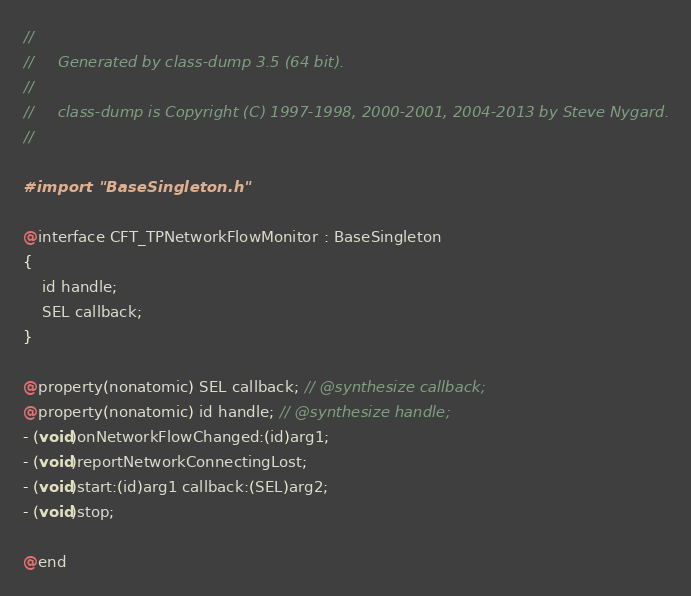<code> <loc_0><loc_0><loc_500><loc_500><_C_>//
//     Generated by class-dump 3.5 (64 bit).
//
//     class-dump is Copyright (C) 1997-1998, 2000-2001, 2004-2013 by Steve Nygard.
//

#import "BaseSingleton.h"

@interface CFT_TPNetworkFlowMonitor : BaseSingleton
{
    id handle;
    SEL callback;
}

@property(nonatomic) SEL callback; // @synthesize callback;
@property(nonatomic) id handle; // @synthesize handle;
- (void)onNetworkFlowChanged:(id)arg1;
- (void)reportNetworkConnectingLost;
- (void)start:(id)arg1 callback:(SEL)arg2;
- (void)stop;

@end

</code> 